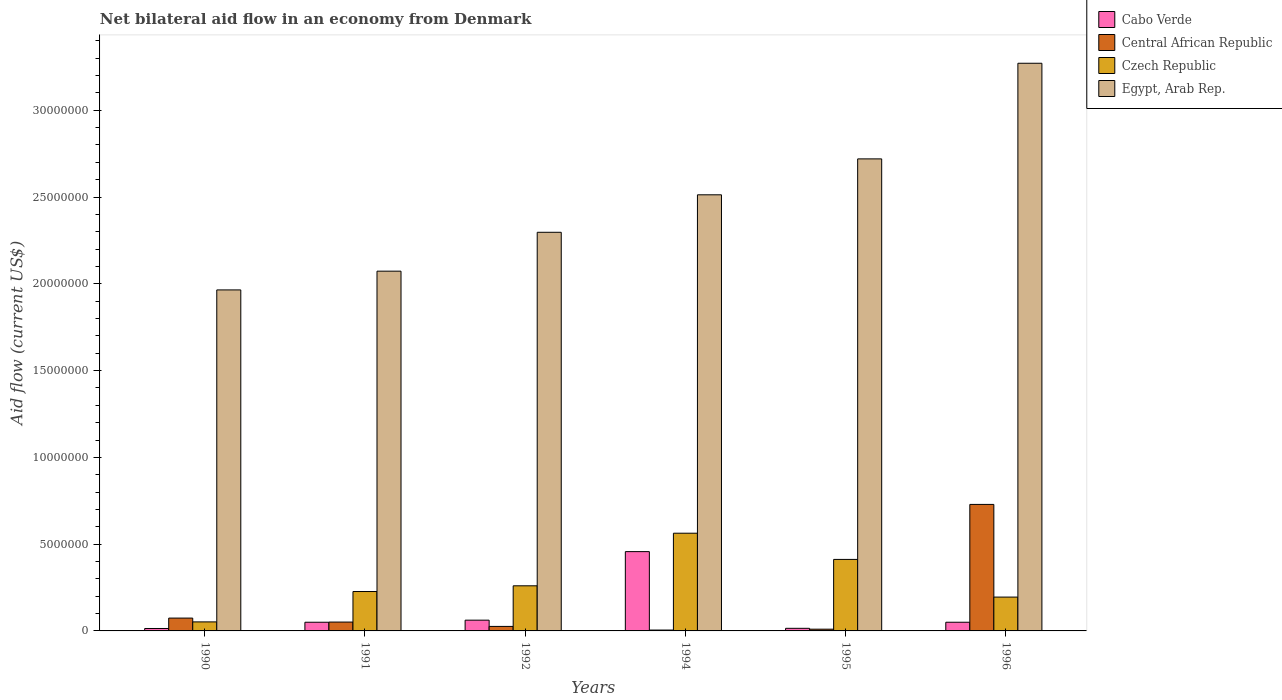Are the number of bars per tick equal to the number of legend labels?
Ensure brevity in your answer.  Yes. In how many cases, is the number of bars for a given year not equal to the number of legend labels?
Keep it short and to the point. 0. What is the net bilateral aid flow in Egypt, Arab Rep. in 1991?
Ensure brevity in your answer.  2.07e+07. Across all years, what is the maximum net bilateral aid flow in Egypt, Arab Rep.?
Give a very brief answer. 3.27e+07. In which year was the net bilateral aid flow in Czech Republic maximum?
Ensure brevity in your answer.  1994. What is the total net bilateral aid flow in Central African Republic in the graph?
Give a very brief answer. 8.95e+06. What is the difference between the net bilateral aid flow in Central African Republic in 1990 and that in 1994?
Make the answer very short. 6.90e+05. What is the difference between the net bilateral aid flow in Czech Republic in 1992 and the net bilateral aid flow in Egypt, Arab Rep. in 1994?
Offer a very short reply. -2.25e+07. What is the average net bilateral aid flow in Egypt, Arab Rep. per year?
Keep it short and to the point. 2.47e+07. In the year 1992, what is the difference between the net bilateral aid flow in Cabo Verde and net bilateral aid flow in Czech Republic?
Keep it short and to the point. -1.98e+06. What is the ratio of the net bilateral aid flow in Central African Republic in 1992 to that in 1996?
Your answer should be compact. 0.04. Is the difference between the net bilateral aid flow in Cabo Verde in 1994 and 1996 greater than the difference between the net bilateral aid flow in Czech Republic in 1994 and 1996?
Give a very brief answer. Yes. What is the difference between the highest and the second highest net bilateral aid flow in Cabo Verde?
Your response must be concise. 3.95e+06. What is the difference between the highest and the lowest net bilateral aid flow in Egypt, Arab Rep.?
Keep it short and to the point. 1.31e+07. In how many years, is the net bilateral aid flow in Egypt, Arab Rep. greater than the average net bilateral aid flow in Egypt, Arab Rep. taken over all years?
Your response must be concise. 3. What does the 3rd bar from the left in 1996 represents?
Provide a succinct answer. Czech Republic. What does the 1st bar from the right in 1991 represents?
Your answer should be compact. Egypt, Arab Rep. Is it the case that in every year, the sum of the net bilateral aid flow in Central African Republic and net bilateral aid flow in Czech Republic is greater than the net bilateral aid flow in Cabo Verde?
Your answer should be very brief. Yes. How many bars are there?
Ensure brevity in your answer.  24. How many years are there in the graph?
Your answer should be very brief. 6. What is the difference between two consecutive major ticks on the Y-axis?
Keep it short and to the point. 5.00e+06. Does the graph contain grids?
Make the answer very short. No. Where does the legend appear in the graph?
Your answer should be compact. Top right. How are the legend labels stacked?
Keep it short and to the point. Vertical. What is the title of the graph?
Your response must be concise. Net bilateral aid flow in an economy from Denmark. What is the Aid flow (current US$) of Central African Republic in 1990?
Ensure brevity in your answer.  7.40e+05. What is the Aid flow (current US$) in Czech Republic in 1990?
Your answer should be compact. 5.20e+05. What is the Aid flow (current US$) in Egypt, Arab Rep. in 1990?
Keep it short and to the point. 1.96e+07. What is the Aid flow (current US$) of Central African Republic in 1991?
Your answer should be very brief. 5.10e+05. What is the Aid flow (current US$) of Czech Republic in 1991?
Keep it short and to the point. 2.27e+06. What is the Aid flow (current US$) of Egypt, Arab Rep. in 1991?
Keep it short and to the point. 2.07e+07. What is the Aid flow (current US$) of Cabo Verde in 1992?
Your answer should be very brief. 6.20e+05. What is the Aid flow (current US$) of Central African Republic in 1992?
Make the answer very short. 2.60e+05. What is the Aid flow (current US$) of Czech Republic in 1992?
Ensure brevity in your answer.  2.60e+06. What is the Aid flow (current US$) of Egypt, Arab Rep. in 1992?
Ensure brevity in your answer.  2.30e+07. What is the Aid flow (current US$) in Cabo Verde in 1994?
Give a very brief answer. 4.57e+06. What is the Aid flow (current US$) of Central African Republic in 1994?
Provide a succinct answer. 5.00e+04. What is the Aid flow (current US$) in Czech Republic in 1994?
Your response must be concise. 5.63e+06. What is the Aid flow (current US$) in Egypt, Arab Rep. in 1994?
Provide a succinct answer. 2.51e+07. What is the Aid flow (current US$) of Cabo Verde in 1995?
Make the answer very short. 1.50e+05. What is the Aid flow (current US$) in Central African Republic in 1995?
Give a very brief answer. 1.00e+05. What is the Aid flow (current US$) of Czech Republic in 1995?
Your answer should be compact. 4.12e+06. What is the Aid flow (current US$) in Egypt, Arab Rep. in 1995?
Ensure brevity in your answer.  2.72e+07. What is the Aid flow (current US$) of Cabo Verde in 1996?
Your answer should be compact. 5.00e+05. What is the Aid flow (current US$) of Central African Republic in 1996?
Provide a succinct answer. 7.29e+06. What is the Aid flow (current US$) of Czech Republic in 1996?
Your answer should be compact. 1.95e+06. What is the Aid flow (current US$) of Egypt, Arab Rep. in 1996?
Offer a very short reply. 3.27e+07. Across all years, what is the maximum Aid flow (current US$) of Cabo Verde?
Make the answer very short. 4.57e+06. Across all years, what is the maximum Aid flow (current US$) in Central African Republic?
Provide a short and direct response. 7.29e+06. Across all years, what is the maximum Aid flow (current US$) in Czech Republic?
Give a very brief answer. 5.63e+06. Across all years, what is the maximum Aid flow (current US$) in Egypt, Arab Rep.?
Provide a short and direct response. 3.27e+07. Across all years, what is the minimum Aid flow (current US$) in Cabo Verde?
Offer a very short reply. 1.40e+05. Across all years, what is the minimum Aid flow (current US$) in Czech Republic?
Offer a terse response. 5.20e+05. Across all years, what is the minimum Aid flow (current US$) of Egypt, Arab Rep.?
Give a very brief answer. 1.96e+07. What is the total Aid flow (current US$) in Cabo Verde in the graph?
Make the answer very short. 6.48e+06. What is the total Aid flow (current US$) of Central African Republic in the graph?
Your response must be concise. 8.95e+06. What is the total Aid flow (current US$) of Czech Republic in the graph?
Provide a succinct answer. 1.71e+07. What is the total Aid flow (current US$) in Egypt, Arab Rep. in the graph?
Make the answer very short. 1.48e+08. What is the difference between the Aid flow (current US$) of Cabo Verde in 1990 and that in 1991?
Your answer should be very brief. -3.60e+05. What is the difference between the Aid flow (current US$) in Central African Republic in 1990 and that in 1991?
Make the answer very short. 2.30e+05. What is the difference between the Aid flow (current US$) in Czech Republic in 1990 and that in 1991?
Your response must be concise. -1.75e+06. What is the difference between the Aid flow (current US$) in Egypt, Arab Rep. in 1990 and that in 1991?
Your answer should be compact. -1.08e+06. What is the difference between the Aid flow (current US$) of Cabo Verde in 1990 and that in 1992?
Your response must be concise. -4.80e+05. What is the difference between the Aid flow (current US$) in Czech Republic in 1990 and that in 1992?
Your answer should be very brief. -2.08e+06. What is the difference between the Aid flow (current US$) of Egypt, Arab Rep. in 1990 and that in 1992?
Make the answer very short. -3.32e+06. What is the difference between the Aid flow (current US$) in Cabo Verde in 1990 and that in 1994?
Make the answer very short. -4.43e+06. What is the difference between the Aid flow (current US$) in Central African Republic in 1990 and that in 1994?
Provide a short and direct response. 6.90e+05. What is the difference between the Aid flow (current US$) in Czech Republic in 1990 and that in 1994?
Make the answer very short. -5.11e+06. What is the difference between the Aid flow (current US$) in Egypt, Arab Rep. in 1990 and that in 1994?
Ensure brevity in your answer.  -5.48e+06. What is the difference between the Aid flow (current US$) in Central African Republic in 1990 and that in 1995?
Offer a terse response. 6.40e+05. What is the difference between the Aid flow (current US$) in Czech Republic in 1990 and that in 1995?
Offer a very short reply. -3.60e+06. What is the difference between the Aid flow (current US$) of Egypt, Arab Rep. in 1990 and that in 1995?
Your answer should be very brief. -7.55e+06. What is the difference between the Aid flow (current US$) in Cabo Verde in 1990 and that in 1996?
Provide a succinct answer. -3.60e+05. What is the difference between the Aid flow (current US$) in Central African Republic in 1990 and that in 1996?
Offer a terse response. -6.55e+06. What is the difference between the Aid flow (current US$) in Czech Republic in 1990 and that in 1996?
Your answer should be compact. -1.43e+06. What is the difference between the Aid flow (current US$) of Egypt, Arab Rep. in 1990 and that in 1996?
Your answer should be very brief. -1.31e+07. What is the difference between the Aid flow (current US$) in Cabo Verde in 1991 and that in 1992?
Offer a very short reply. -1.20e+05. What is the difference between the Aid flow (current US$) in Czech Republic in 1991 and that in 1992?
Give a very brief answer. -3.30e+05. What is the difference between the Aid flow (current US$) of Egypt, Arab Rep. in 1991 and that in 1992?
Make the answer very short. -2.24e+06. What is the difference between the Aid flow (current US$) in Cabo Verde in 1991 and that in 1994?
Ensure brevity in your answer.  -4.07e+06. What is the difference between the Aid flow (current US$) in Czech Republic in 1991 and that in 1994?
Ensure brevity in your answer.  -3.36e+06. What is the difference between the Aid flow (current US$) in Egypt, Arab Rep. in 1991 and that in 1994?
Provide a succinct answer. -4.40e+06. What is the difference between the Aid flow (current US$) in Cabo Verde in 1991 and that in 1995?
Your response must be concise. 3.50e+05. What is the difference between the Aid flow (current US$) in Central African Republic in 1991 and that in 1995?
Your answer should be compact. 4.10e+05. What is the difference between the Aid flow (current US$) in Czech Republic in 1991 and that in 1995?
Your answer should be very brief. -1.85e+06. What is the difference between the Aid flow (current US$) in Egypt, Arab Rep. in 1991 and that in 1995?
Provide a short and direct response. -6.47e+06. What is the difference between the Aid flow (current US$) in Central African Republic in 1991 and that in 1996?
Offer a very short reply. -6.78e+06. What is the difference between the Aid flow (current US$) of Czech Republic in 1991 and that in 1996?
Ensure brevity in your answer.  3.20e+05. What is the difference between the Aid flow (current US$) in Egypt, Arab Rep. in 1991 and that in 1996?
Ensure brevity in your answer.  -1.20e+07. What is the difference between the Aid flow (current US$) in Cabo Verde in 1992 and that in 1994?
Offer a terse response. -3.95e+06. What is the difference between the Aid flow (current US$) of Czech Republic in 1992 and that in 1994?
Give a very brief answer. -3.03e+06. What is the difference between the Aid flow (current US$) of Egypt, Arab Rep. in 1992 and that in 1994?
Offer a very short reply. -2.16e+06. What is the difference between the Aid flow (current US$) in Czech Republic in 1992 and that in 1995?
Ensure brevity in your answer.  -1.52e+06. What is the difference between the Aid flow (current US$) in Egypt, Arab Rep. in 1992 and that in 1995?
Provide a short and direct response. -4.23e+06. What is the difference between the Aid flow (current US$) of Central African Republic in 1992 and that in 1996?
Offer a very short reply. -7.03e+06. What is the difference between the Aid flow (current US$) in Czech Republic in 1992 and that in 1996?
Offer a terse response. 6.50e+05. What is the difference between the Aid flow (current US$) of Egypt, Arab Rep. in 1992 and that in 1996?
Offer a terse response. -9.74e+06. What is the difference between the Aid flow (current US$) of Cabo Verde in 1994 and that in 1995?
Make the answer very short. 4.42e+06. What is the difference between the Aid flow (current US$) in Czech Republic in 1994 and that in 1995?
Provide a short and direct response. 1.51e+06. What is the difference between the Aid flow (current US$) in Egypt, Arab Rep. in 1994 and that in 1995?
Provide a short and direct response. -2.07e+06. What is the difference between the Aid flow (current US$) of Cabo Verde in 1994 and that in 1996?
Make the answer very short. 4.07e+06. What is the difference between the Aid flow (current US$) in Central African Republic in 1994 and that in 1996?
Ensure brevity in your answer.  -7.24e+06. What is the difference between the Aid flow (current US$) of Czech Republic in 1994 and that in 1996?
Give a very brief answer. 3.68e+06. What is the difference between the Aid flow (current US$) of Egypt, Arab Rep. in 1994 and that in 1996?
Offer a very short reply. -7.58e+06. What is the difference between the Aid flow (current US$) in Cabo Verde in 1995 and that in 1996?
Ensure brevity in your answer.  -3.50e+05. What is the difference between the Aid flow (current US$) in Central African Republic in 1995 and that in 1996?
Offer a terse response. -7.19e+06. What is the difference between the Aid flow (current US$) of Czech Republic in 1995 and that in 1996?
Ensure brevity in your answer.  2.17e+06. What is the difference between the Aid flow (current US$) in Egypt, Arab Rep. in 1995 and that in 1996?
Provide a short and direct response. -5.51e+06. What is the difference between the Aid flow (current US$) of Cabo Verde in 1990 and the Aid flow (current US$) of Central African Republic in 1991?
Make the answer very short. -3.70e+05. What is the difference between the Aid flow (current US$) of Cabo Verde in 1990 and the Aid flow (current US$) of Czech Republic in 1991?
Keep it short and to the point. -2.13e+06. What is the difference between the Aid flow (current US$) in Cabo Verde in 1990 and the Aid flow (current US$) in Egypt, Arab Rep. in 1991?
Your answer should be compact. -2.06e+07. What is the difference between the Aid flow (current US$) of Central African Republic in 1990 and the Aid flow (current US$) of Czech Republic in 1991?
Offer a very short reply. -1.53e+06. What is the difference between the Aid flow (current US$) of Central African Republic in 1990 and the Aid flow (current US$) of Egypt, Arab Rep. in 1991?
Your response must be concise. -2.00e+07. What is the difference between the Aid flow (current US$) in Czech Republic in 1990 and the Aid flow (current US$) in Egypt, Arab Rep. in 1991?
Your answer should be very brief. -2.02e+07. What is the difference between the Aid flow (current US$) of Cabo Verde in 1990 and the Aid flow (current US$) of Czech Republic in 1992?
Keep it short and to the point. -2.46e+06. What is the difference between the Aid flow (current US$) of Cabo Verde in 1990 and the Aid flow (current US$) of Egypt, Arab Rep. in 1992?
Ensure brevity in your answer.  -2.28e+07. What is the difference between the Aid flow (current US$) in Central African Republic in 1990 and the Aid flow (current US$) in Czech Republic in 1992?
Make the answer very short. -1.86e+06. What is the difference between the Aid flow (current US$) of Central African Republic in 1990 and the Aid flow (current US$) of Egypt, Arab Rep. in 1992?
Give a very brief answer. -2.22e+07. What is the difference between the Aid flow (current US$) in Czech Republic in 1990 and the Aid flow (current US$) in Egypt, Arab Rep. in 1992?
Your answer should be compact. -2.24e+07. What is the difference between the Aid flow (current US$) in Cabo Verde in 1990 and the Aid flow (current US$) in Central African Republic in 1994?
Give a very brief answer. 9.00e+04. What is the difference between the Aid flow (current US$) in Cabo Verde in 1990 and the Aid flow (current US$) in Czech Republic in 1994?
Offer a very short reply. -5.49e+06. What is the difference between the Aid flow (current US$) in Cabo Verde in 1990 and the Aid flow (current US$) in Egypt, Arab Rep. in 1994?
Provide a short and direct response. -2.50e+07. What is the difference between the Aid flow (current US$) in Central African Republic in 1990 and the Aid flow (current US$) in Czech Republic in 1994?
Ensure brevity in your answer.  -4.89e+06. What is the difference between the Aid flow (current US$) in Central African Republic in 1990 and the Aid flow (current US$) in Egypt, Arab Rep. in 1994?
Provide a short and direct response. -2.44e+07. What is the difference between the Aid flow (current US$) in Czech Republic in 1990 and the Aid flow (current US$) in Egypt, Arab Rep. in 1994?
Provide a short and direct response. -2.46e+07. What is the difference between the Aid flow (current US$) of Cabo Verde in 1990 and the Aid flow (current US$) of Czech Republic in 1995?
Keep it short and to the point. -3.98e+06. What is the difference between the Aid flow (current US$) in Cabo Verde in 1990 and the Aid flow (current US$) in Egypt, Arab Rep. in 1995?
Give a very brief answer. -2.71e+07. What is the difference between the Aid flow (current US$) in Central African Republic in 1990 and the Aid flow (current US$) in Czech Republic in 1995?
Your answer should be very brief. -3.38e+06. What is the difference between the Aid flow (current US$) of Central African Republic in 1990 and the Aid flow (current US$) of Egypt, Arab Rep. in 1995?
Ensure brevity in your answer.  -2.65e+07. What is the difference between the Aid flow (current US$) of Czech Republic in 1990 and the Aid flow (current US$) of Egypt, Arab Rep. in 1995?
Provide a succinct answer. -2.67e+07. What is the difference between the Aid flow (current US$) of Cabo Verde in 1990 and the Aid flow (current US$) of Central African Republic in 1996?
Provide a short and direct response. -7.15e+06. What is the difference between the Aid flow (current US$) in Cabo Verde in 1990 and the Aid flow (current US$) in Czech Republic in 1996?
Your answer should be very brief. -1.81e+06. What is the difference between the Aid flow (current US$) of Cabo Verde in 1990 and the Aid flow (current US$) of Egypt, Arab Rep. in 1996?
Offer a terse response. -3.26e+07. What is the difference between the Aid flow (current US$) in Central African Republic in 1990 and the Aid flow (current US$) in Czech Republic in 1996?
Make the answer very short. -1.21e+06. What is the difference between the Aid flow (current US$) in Central African Republic in 1990 and the Aid flow (current US$) in Egypt, Arab Rep. in 1996?
Keep it short and to the point. -3.20e+07. What is the difference between the Aid flow (current US$) of Czech Republic in 1990 and the Aid flow (current US$) of Egypt, Arab Rep. in 1996?
Offer a very short reply. -3.22e+07. What is the difference between the Aid flow (current US$) of Cabo Verde in 1991 and the Aid flow (current US$) of Central African Republic in 1992?
Offer a very short reply. 2.40e+05. What is the difference between the Aid flow (current US$) in Cabo Verde in 1991 and the Aid flow (current US$) in Czech Republic in 1992?
Your response must be concise. -2.10e+06. What is the difference between the Aid flow (current US$) of Cabo Verde in 1991 and the Aid flow (current US$) of Egypt, Arab Rep. in 1992?
Make the answer very short. -2.25e+07. What is the difference between the Aid flow (current US$) of Central African Republic in 1991 and the Aid flow (current US$) of Czech Republic in 1992?
Your answer should be compact. -2.09e+06. What is the difference between the Aid flow (current US$) in Central African Republic in 1991 and the Aid flow (current US$) in Egypt, Arab Rep. in 1992?
Your response must be concise. -2.25e+07. What is the difference between the Aid flow (current US$) in Czech Republic in 1991 and the Aid flow (current US$) in Egypt, Arab Rep. in 1992?
Make the answer very short. -2.07e+07. What is the difference between the Aid flow (current US$) of Cabo Verde in 1991 and the Aid flow (current US$) of Czech Republic in 1994?
Give a very brief answer. -5.13e+06. What is the difference between the Aid flow (current US$) in Cabo Verde in 1991 and the Aid flow (current US$) in Egypt, Arab Rep. in 1994?
Give a very brief answer. -2.46e+07. What is the difference between the Aid flow (current US$) of Central African Republic in 1991 and the Aid flow (current US$) of Czech Republic in 1994?
Ensure brevity in your answer.  -5.12e+06. What is the difference between the Aid flow (current US$) of Central African Republic in 1991 and the Aid flow (current US$) of Egypt, Arab Rep. in 1994?
Offer a terse response. -2.46e+07. What is the difference between the Aid flow (current US$) in Czech Republic in 1991 and the Aid flow (current US$) in Egypt, Arab Rep. in 1994?
Provide a short and direct response. -2.29e+07. What is the difference between the Aid flow (current US$) of Cabo Verde in 1991 and the Aid flow (current US$) of Central African Republic in 1995?
Your answer should be compact. 4.00e+05. What is the difference between the Aid flow (current US$) of Cabo Verde in 1991 and the Aid flow (current US$) of Czech Republic in 1995?
Make the answer very short. -3.62e+06. What is the difference between the Aid flow (current US$) in Cabo Verde in 1991 and the Aid flow (current US$) in Egypt, Arab Rep. in 1995?
Offer a terse response. -2.67e+07. What is the difference between the Aid flow (current US$) in Central African Republic in 1991 and the Aid flow (current US$) in Czech Republic in 1995?
Provide a succinct answer. -3.61e+06. What is the difference between the Aid flow (current US$) of Central African Republic in 1991 and the Aid flow (current US$) of Egypt, Arab Rep. in 1995?
Keep it short and to the point. -2.67e+07. What is the difference between the Aid flow (current US$) of Czech Republic in 1991 and the Aid flow (current US$) of Egypt, Arab Rep. in 1995?
Ensure brevity in your answer.  -2.49e+07. What is the difference between the Aid flow (current US$) in Cabo Verde in 1991 and the Aid flow (current US$) in Central African Republic in 1996?
Offer a very short reply. -6.79e+06. What is the difference between the Aid flow (current US$) in Cabo Verde in 1991 and the Aid flow (current US$) in Czech Republic in 1996?
Make the answer very short. -1.45e+06. What is the difference between the Aid flow (current US$) in Cabo Verde in 1991 and the Aid flow (current US$) in Egypt, Arab Rep. in 1996?
Provide a short and direct response. -3.22e+07. What is the difference between the Aid flow (current US$) in Central African Republic in 1991 and the Aid flow (current US$) in Czech Republic in 1996?
Your response must be concise. -1.44e+06. What is the difference between the Aid flow (current US$) in Central African Republic in 1991 and the Aid flow (current US$) in Egypt, Arab Rep. in 1996?
Give a very brief answer. -3.22e+07. What is the difference between the Aid flow (current US$) of Czech Republic in 1991 and the Aid flow (current US$) of Egypt, Arab Rep. in 1996?
Provide a succinct answer. -3.04e+07. What is the difference between the Aid flow (current US$) of Cabo Verde in 1992 and the Aid flow (current US$) of Central African Republic in 1994?
Offer a very short reply. 5.70e+05. What is the difference between the Aid flow (current US$) in Cabo Verde in 1992 and the Aid flow (current US$) in Czech Republic in 1994?
Your answer should be compact. -5.01e+06. What is the difference between the Aid flow (current US$) in Cabo Verde in 1992 and the Aid flow (current US$) in Egypt, Arab Rep. in 1994?
Ensure brevity in your answer.  -2.45e+07. What is the difference between the Aid flow (current US$) of Central African Republic in 1992 and the Aid flow (current US$) of Czech Republic in 1994?
Your response must be concise. -5.37e+06. What is the difference between the Aid flow (current US$) in Central African Republic in 1992 and the Aid flow (current US$) in Egypt, Arab Rep. in 1994?
Keep it short and to the point. -2.49e+07. What is the difference between the Aid flow (current US$) of Czech Republic in 1992 and the Aid flow (current US$) of Egypt, Arab Rep. in 1994?
Provide a succinct answer. -2.25e+07. What is the difference between the Aid flow (current US$) of Cabo Verde in 1992 and the Aid flow (current US$) of Central African Republic in 1995?
Your response must be concise. 5.20e+05. What is the difference between the Aid flow (current US$) in Cabo Verde in 1992 and the Aid flow (current US$) in Czech Republic in 1995?
Ensure brevity in your answer.  -3.50e+06. What is the difference between the Aid flow (current US$) of Cabo Verde in 1992 and the Aid flow (current US$) of Egypt, Arab Rep. in 1995?
Provide a short and direct response. -2.66e+07. What is the difference between the Aid flow (current US$) of Central African Republic in 1992 and the Aid flow (current US$) of Czech Republic in 1995?
Keep it short and to the point. -3.86e+06. What is the difference between the Aid flow (current US$) in Central African Republic in 1992 and the Aid flow (current US$) in Egypt, Arab Rep. in 1995?
Ensure brevity in your answer.  -2.69e+07. What is the difference between the Aid flow (current US$) of Czech Republic in 1992 and the Aid flow (current US$) of Egypt, Arab Rep. in 1995?
Your response must be concise. -2.46e+07. What is the difference between the Aid flow (current US$) of Cabo Verde in 1992 and the Aid flow (current US$) of Central African Republic in 1996?
Offer a very short reply. -6.67e+06. What is the difference between the Aid flow (current US$) in Cabo Verde in 1992 and the Aid flow (current US$) in Czech Republic in 1996?
Provide a succinct answer. -1.33e+06. What is the difference between the Aid flow (current US$) of Cabo Verde in 1992 and the Aid flow (current US$) of Egypt, Arab Rep. in 1996?
Make the answer very short. -3.21e+07. What is the difference between the Aid flow (current US$) in Central African Republic in 1992 and the Aid flow (current US$) in Czech Republic in 1996?
Provide a succinct answer. -1.69e+06. What is the difference between the Aid flow (current US$) of Central African Republic in 1992 and the Aid flow (current US$) of Egypt, Arab Rep. in 1996?
Ensure brevity in your answer.  -3.24e+07. What is the difference between the Aid flow (current US$) in Czech Republic in 1992 and the Aid flow (current US$) in Egypt, Arab Rep. in 1996?
Provide a succinct answer. -3.01e+07. What is the difference between the Aid flow (current US$) in Cabo Verde in 1994 and the Aid flow (current US$) in Central African Republic in 1995?
Your answer should be very brief. 4.47e+06. What is the difference between the Aid flow (current US$) of Cabo Verde in 1994 and the Aid flow (current US$) of Czech Republic in 1995?
Offer a terse response. 4.50e+05. What is the difference between the Aid flow (current US$) of Cabo Verde in 1994 and the Aid flow (current US$) of Egypt, Arab Rep. in 1995?
Your answer should be very brief. -2.26e+07. What is the difference between the Aid flow (current US$) in Central African Republic in 1994 and the Aid flow (current US$) in Czech Republic in 1995?
Provide a short and direct response. -4.07e+06. What is the difference between the Aid flow (current US$) in Central African Republic in 1994 and the Aid flow (current US$) in Egypt, Arab Rep. in 1995?
Your answer should be compact. -2.72e+07. What is the difference between the Aid flow (current US$) of Czech Republic in 1994 and the Aid flow (current US$) of Egypt, Arab Rep. in 1995?
Offer a terse response. -2.16e+07. What is the difference between the Aid flow (current US$) of Cabo Verde in 1994 and the Aid flow (current US$) of Central African Republic in 1996?
Provide a short and direct response. -2.72e+06. What is the difference between the Aid flow (current US$) in Cabo Verde in 1994 and the Aid flow (current US$) in Czech Republic in 1996?
Your answer should be compact. 2.62e+06. What is the difference between the Aid flow (current US$) in Cabo Verde in 1994 and the Aid flow (current US$) in Egypt, Arab Rep. in 1996?
Ensure brevity in your answer.  -2.81e+07. What is the difference between the Aid flow (current US$) in Central African Republic in 1994 and the Aid flow (current US$) in Czech Republic in 1996?
Give a very brief answer. -1.90e+06. What is the difference between the Aid flow (current US$) of Central African Republic in 1994 and the Aid flow (current US$) of Egypt, Arab Rep. in 1996?
Provide a short and direct response. -3.27e+07. What is the difference between the Aid flow (current US$) in Czech Republic in 1994 and the Aid flow (current US$) in Egypt, Arab Rep. in 1996?
Provide a succinct answer. -2.71e+07. What is the difference between the Aid flow (current US$) in Cabo Verde in 1995 and the Aid flow (current US$) in Central African Republic in 1996?
Offer a very short reply. -7.14e+06. What is the difference between the Aid flow (current US$) of Cabo Verde in 1995 and the Aid flow (current US$) of Czech Republic in 1996?
Keep it short and to the point. -1.80e+06. What is the difference between the Aid flow (current US$) of Cabo Verde in 1995 and the Aid flow (current US$) of Egypt, Arab Rep. in 1996?
Provide a succinct answer. -3.26e+07. What is the difference between the Aid flow (current US$) in Central African Republic in 1995 and the Aid flow (current US$) in Czech Republic in 1996?
Offer a very short reply. -1.85e+06. What is the difference between the Aid flow (current US$) of Central African Republic in 1995 and the Aid flow (current US$) of Egypt, Arab Rep. in 1996?
Keep it short and to the point. -3.26e+07. What is the difference between the Aid flow (current US$) of Czech Republic in 1995 and the Aid flow (current US$) of Egypt, Arab Rep. in 1996?
Give a very brief answer. -2.86e+07. What is the average Aid flow (current US$) in Cabo Verde per year?
Give a very brief answer. 1.08e+06. What is the average Aid flow (current US$) in Central African Republic per year?
Your answer should be compact. 1.49e+06. What is the average Aid flow (current US$) in Czech Republic per year?
Your answer should be compact. 2.85e+06. What is the average Aid flow (current US$) in Egypt, Arab Rep. per year?
Your answer should be compact. 2.47e+07. In the year 1990, what is the difference between the Aid flow (current US$) of Cabo Verde and Aid flow (current US$) of Central African Republic?
Offer a terse response. -6.00e+05. In the year 1990, what is the difference between the Aid flow (current US$) in Cabo Verde and Aid flow (current US$) in Czech Republic?
Ensure brevity in your answer.  -3.80e+05. In the year 1990, what is the difference between the Aid flow (current US$) of Cabo Verde and Aid flow (current US$) of Egypt, Arab Rep.?
Keep it short and to the point. -1.95e+07. In the year 1990, what is the difference between the Aid flow (current US$) of Central African Republic and Aid flow (current US$) of Czech Republic?
Make the answer very short. 2.20e+05. In the year 1990, what is the difference between the Aid flow (current US$) of Central African Republic and Aid flow (current US$) of Egypt, Arab Rep.?
Provide a short and direct response. -1.89e+07. In the year 1990, what is the difference between the Aid flow (current US$) in Czech Republic and Aid flow (current US$) in Egypt, Arab Rep.?
Make the answer very short. -1.91e+07. In the year 1991, what is the difference between the Aid flow (current US$) of Cabo Verde and Aid flow (current US$) of Central African Republic?
Offer a very short reply. -10000. In the year 1991, what is the difference between the Aid flow (current US$) in Cabo Verde and Aid flow (current US$) in Czech Republic?
Give a very brief answer. -1.77e+06. In the year 1991, what is the difference between the Aid flow (current US$) in Cabo Verde and Aid flow (current US$) in Egypt, Arab Rep.?
Offer a very short reply. -2.02e+07. In the year 1991, what is the difference between the Aid flow (current US$) in Central African Republic and Aid flow (current US$) in Czech Republic?
Provide a short and direct response. -1.76e+06. In the year 1991, what is the difference between the Aid flow (current US$) in Central African Republic and Aid flow (current US$) in Egypt, Arab Rep.?
Provide a succinct answer. -2.02e+07. In the year 1991, what is the difference between the Aid flow (current US$) of Czech Republic and Aid flow (current US$) of Egypt, Arab Rep.?
Provide a short and direct response. -1.85e+07. In the year 1992, what is the difference between the Aid flow (current US$) of Cabo Verde and Aid flow (current US$) of Central African Republic?
Your answer should be very brief. 3.60e+05. In the year 1992, what is the difference between the Aid flow (current US$) in Cabo Verde and Aid flow (current US$) in Czech Republic?
Offer a terse response. -1.98e+06. In the year 1992, what is the difference between the Aid flow (current US$) of Cabo Verde and Aid flow (current US$) of Egypt, Arab Rep.?
Give a very brief answer. -2.24e+07. In the year 1992, what is the difference between the Aid flow (current US$) in Central African Republic and Aid flow (current US$) in Czech Republic?
Offer a terse response. -2.34e+06. In the year 1992, what is the difference between the Aid flow (current US$) in Central African Republic and Aid flow (current US$) in Egypt, Arab Rep.?
Keep it short and to the point. -2.27e+07. In the year 1992, what is the difference between the Aid flow (current US$) in Czech Republic and Aid flow (current US$) in Egypt, Arab Rep.?
Your answer should be compact. -2.04e+07. In the year 1994, what is the difference between the Aid flow (current US$) of Cabo Verde and Aid flow (current US$) of Central African Republic?
Your response must be concise. 4.52e+06. In the year 1994, what is the difference between the Aid flow (current US$) of Cabo Verde and Aid flow (current US$) of Czech Republic?
Your response must be concise. -1.06e+06. In the year 1994, what is the difference between the Aid flow (current US$) in Cabo Verde and Aid flow (current US$) in Egypt, Arab Rep.?
Your response must be concise. -2.06e+07. In the year 1994, what is the difference between the Aid flow (current US$) of Central African Republic and Aid flow (current US$) of Czech Republic?
Your answer should be very brief. -5.58e+06. In the year 1994, what is the difference between the Aid flow (current US$) in Central African Republic and Aid flow (current US$) in Egypt, Arab Rep.?
Give a very brief answer. -2.51e+07. In the year 1994, what is the difference between the Aid flow (current US$) in Czech Republic and Aid flow (current US$) in Egypt, Arab Rep.?
Provide a succinct answer. -1.95e+07. In the year 1995, what is the difference between the Aid flow (current US$) of Cabo Verde and Aid flow (current US$) of Central African Republic?
Offer a very short reply. 5.00e+04. In the year 1995, what is the difference between the Aid flow (current US$) in Cabo Verde and Aid flow (current US$) in Czech Republic?
Your answer should be very brief. -3.97e+06. In the year 1995, what is the difference between the Aid flow (current US$) of Cabo Verde and Aid flow (current US$) of Egypt, Arab Rep.?
Provide a succinct answer. -2.70e+07. In the year 1995, what is the difference between the Aid flow (current US$) in Central African Republic and Aid flow (current US$) in Czech Republic?
Your response must be concise. -4.02e+06. In the year 1995, what is the difference between the Aid flow (current US$) in Central African Republic and Aid flow (current US$) in Egypt, Arab Rep.?
Offer a terse response. -2.71e+07. In the year 1995, what is the difference between the Aid flow (current US$) of Czech Republic and Aid flow (current US$) of Egypt, Arab Rep.?
Your answer should be very brief. -2.31e+07. In the year 1996, what is the difference between the Aid flow (current US$) in Cabo Verde and Aid flow (current US$) in Central African Republic?
Offer a terse response. -6.79e+06. In the year 1996, what is the difference between the Aid flow (current US$) of Cabo Verde and Aid flow (current US$) of Czech Republic?
Your response must be concise. -1.45e+06. In the year 1996, what is the difference between the Aid flow (current US$) of Cabo Verde and Aid flow (current US$) of Egypt, Arab Rep.?
Provide a succinct answer. -3.22e+07. In the year 1996, what is the difference between the Aid flow (current US$) in Central African Republic and Aid flow (current US$) in Czech Republic?
Make the answer very short. 5.34e+06. In the year 1996, what is the difference between the Aid flow (current US$) in Central African Republic and Aid flow (current US$) in Egypt, Arab Rep.?
Your answer should be compact. -2.54e+07. In the year 1996, what is the difference between the Aid flow (current US$) of Czech Republic and Aid flow (current US$) of Egypt, Arab Rep.?
Offer a very short reply. -3.08e+07. What is the ratio of the Aid flow (current US$) in Cabo Verde in 1990 to that in 1991?
Give a very brief answer. 0.28. What is the ratio of the Aid flow (current US$) of Central African Republic in 1990 to that in 1991?
Provide a succinct answer. 1.45. What is the ratio of the Aid flow (current US$) in Czech Republic in 1990 to that in 1991?
Keep it short and to the point. 0.23. What is the ratio of the Aid flow (current US$) in Egypt, Arab Rep. in 1990 to that in 1991?
Provide a short and direct response. 0.95. What is the ratio of the Aid flow (current US$) of Cabo Verde in 1990 to that in 1992?
Offer a very short reply. 0.23. What is the ratio of the Aid flow (current US$) in Central African Republic in 1990 to that in 1992?
Your response must be concise. 2.85. What is the ratio of the Aid flow (current US$) of Egypt, Arab Rep. in 1990 to that in 1992?
Give a very brief answer. 0.86. What is the ratio of the Aid flow (current US$) of Cabo Verde in 1990 to that in 1994?
Offer a very short reply. 0.03. What is the ratio of the Aid flow (current US$) in Czech Republic in 1990 to that in 1994?
Ensure brevity in your answer.  0.09. What is the ratio of the Aid flow (current US$) of Egypt, Arab Rep. in 1990 to that in 1994?
Your answer should be very brief. 0.78. What is the ratio of the Aid flow (current US$) of Central African Republic in 1990 to that in 1995?
Your response must be concise. 7.4. What is the ratio of the Aid flow (current US$) of Czech Republic in 1990 to that in 1995?
Provide a short and direct response. 0.13. What is the ratio of the Aid flow (current US$) in Egypt, Arab Rep. in 1990 to that in 1995?
Ensure brevity in your answer.  0.72. What is the ratio of the Aid flow (current US$) of Cabo Verde in 1990 to that in 1996?
Provide a short and direct response. 0.28. What is the ratio of the Aid flow (current US$) of Central African Republic in 1990 to that in 1996?
Your answer should be very brief. 0.1. What is the ratio of the Aid flow (current US$) in Czech Republic in 1990 to that in 1996?
Your response must be concise. 0.27. What is the ratio of the Aid flow (current US$) of Egypt, Arab Rep. in 1990 to that in 1996?
Provide a succinct answer. 0.6. What is the ratio of the Aid flow (current US$) in Cabo Verde in 1991 to that in 1992?
Your answer should be compact. 0.81. What is the ratio of the Aid flow (current US$) in Central African Republic in 1991 to that in 1992?
Your response must be concise. 1.96. What is the ratio of the Aid flow (current US$) of Czech Republic in 1991 to that in 1992?
Make the answer very short. 0.87. What is the ratio of the Aid flow (current US$) of Egypt, Arab Rep. in 1991 to that in 1992?
Ensure brevity in your answer.  0.9. What is the ratio of the Aid flow (current US$) of Cabo Verde in 1991 to that in 1994?
Your response must be concise. 0.11. What is the ratio of the Aid flow (current US$) in Czech Republic in 1991 to that in 1994?
Your answer should be compact. 0.4. What is the ratio of the Aid flow (current US$) of Egypt, Arab Rep. in 1991 to that in 1994?
Offer a terse response. 0.82. What is the ratio of the Aid flow (current US$) of Central African Republic in 1991 to that in 1995?
Give a very brief answer. 5.1. What is the ratio of the Aid flow (current US$) in Czech Republic in 1991 to that in 1995?
Offer a very short reply. 0.55. What is the ratio of the Aid flow (current US$) of Egypt, Arab Rep. in 1991 to that in 1995?
Ensure brevity in your answer.  0.76. What is the ratio of the Aid flow (current US$) of Cabo Verde in 1991 to that in 1996?
Make the answer very short. 1. What is the ratio of the Aid flow (current US$) of Central African Republic in 1991 to that in 1996?
Ensure brevity in your answer.  0.07. What is the ratio of the Aid flow (current US$) in Czech Republic in 1991 to that in 1996?
Keep it short and to the point. 1.16. What is the ratio of the Aid flow (current US$) of Egypt, Arab Rep. in 1991 to that in 1996?
Provide a short and direct response. 0.63. What is the ratio of the Aid flow (current US$) in Cabo Verde in 1992 to that in 1994?
Make the answer very short. 0.14. What is the ratio of the Aid flow (current US$) of Czech Republic in 1992 to that in 1994?
Provide a succinct answer. 0.46. What is the ratio of the Aid flow (current US$) in Egypt, Arab Rep. in 1992 to that in 1994?
Make the answer very short. 0.91. What is the ratio of the Aid flow (current US$) of Cabo Verde in 1992 to that in 1995?
Offer a terse response. 4.13. What is the ratio of the Aid flow (current US$) in Czech Republic in 1992 to that in 1995?
Your response must be concise. 0.63. What is the ratio of the Aid flow (current US$) in Egypt, Arab Rep. in 1992 to that in 1995?
Make the answer very short. 0.84. What is the ratio of the Aid flow (current US$) of Cabo Verde in 1992 to that in 1996?
Your answer should be very brief. 1.24. What is the ratio of the Aid flow (current US$) of Central African Republic in 1992 to that in 1996?
Your response must be concise. 0.04. What is the ratio of the Aid flow (current US$) in Czech Republic in 1992 to that in 1996?
Provide a succinct answer. 1.33. What is the ratio of the Aid flow (current US$) of Egypt, Arab Rep. in 1992 to that in 1996?
Make the answer very short. 0.7. What is the ratio of the Aid flow (current US$) of Cabo Verde in 1994 to that in 1995?
Keep it short and to the point. 30.47. What is the ratio of the Aid flow (current US$) in Central African Republic in 1994 to that in 1995?
Make the answer very short. 0.5. What is the ratio of the Aid flow (current US$) in Czech Republic in 1994 to that in 1995?
Keep it short and to the point. 1.37. What is the ratio of the Aid flow (current US$) in Egypt, Arab Rep. in 1994 to that in 1995?
Your response must be concise. 0.92. What is the ratio of the Aid flow (current US$) of Cabo Verde in 1994 to that in 1996?
Ensure brevity in your answer.  9.14. What is the ratio of the Aid flow (current US$) in Central African Republic in 1994 to that in 1996?
Provide a short and direct response. 0.01. What is the ratio of the Aid flow (current US$) in Czech Republic in 1994 to that in 1996?
Give a very brief answer. 2.89. What is the ratio of the Aid flow (current US$) in Egypt, Arab Rep. in 1994 to that in 1996?
Make the answer very short. 0.77. What is the ratio of the Aid flow (current US$) of Central African Republic in 1995 to that in 1996?
Make the answer very short. 0.01. What is the ratio of the Aid flow (current US$) in Czech Republic in 1995 to that in 1996?
Provide a succinct answer. 2.11. What is the ratio of the Aid flow (current US$) in Egypt, Arab Rep. in 1995 to that in 1996?
Make the answer very short. 0.83. What is the difference between the highest and the second highest Aid flow (current US$) of Cabo Verde?
Give a very brief answer. 3.95e+06. What is the difference between the highest and the second highest Aid flow (current US$) in Central African Republic?
Offer a terse response. 6.55e+06. What is the difference between the highest and the second highest Aid flow (current US$) in Czech Republic?
Keep it short and to the point. 1.51e+06. What is the difference between the highest and the second highest Aid flow (current US$) in Egypt, Arab Rep.?
Keep it short and to the point. 5.51e+06. What is the difference between the highest and the lowest Aid flow (current US$) in Cabo Verde?
Give a very brief answer. 4.43e+06. What is the difference between the highest and the lowest Aid flow (current US$) in Central African Republic?
Offer a terse response. 7.24e+06. What is the difference between the highest and the lowest Aid flow (current US$) of Czech Republic?
Offer a terse response. 5.11e+06. What is the difference between the highest and the lowest Aid flow (current US$) of Egypt, Arab Rep.?
Provide a succinct answer. 1.31e+07. 